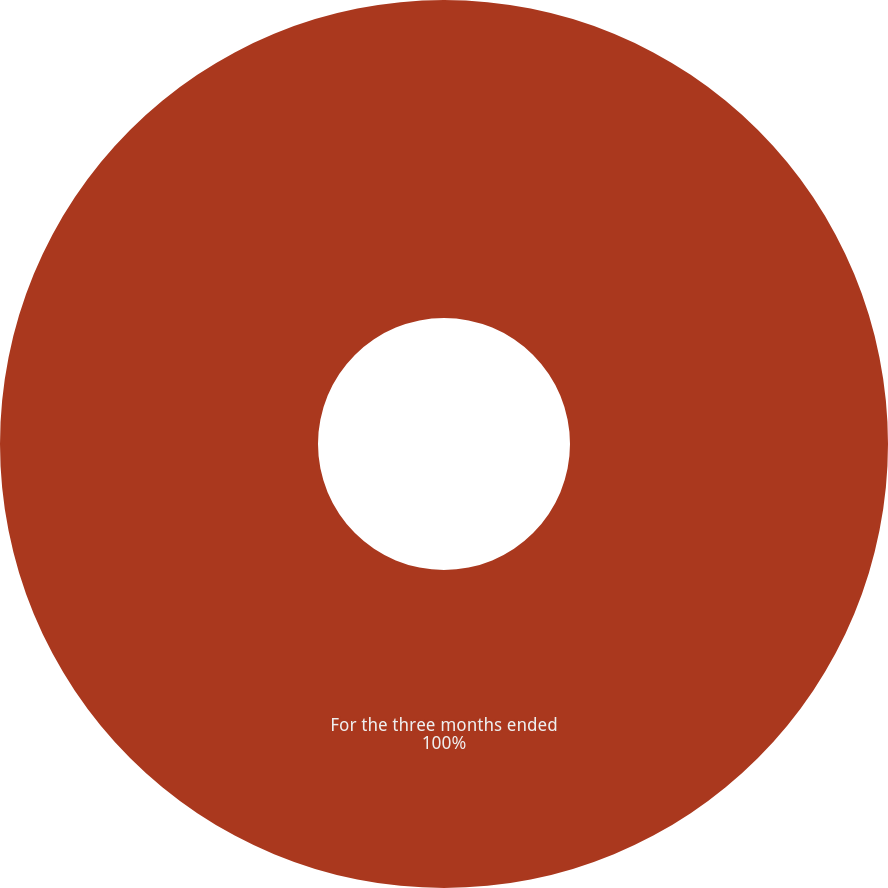Convert chart to OTSL. <chart><loc_0><loc_0><loc_500><loc_500><pie_chart><fcel>For the three months ended<nl><fcel>100.0%<nl></chart> 